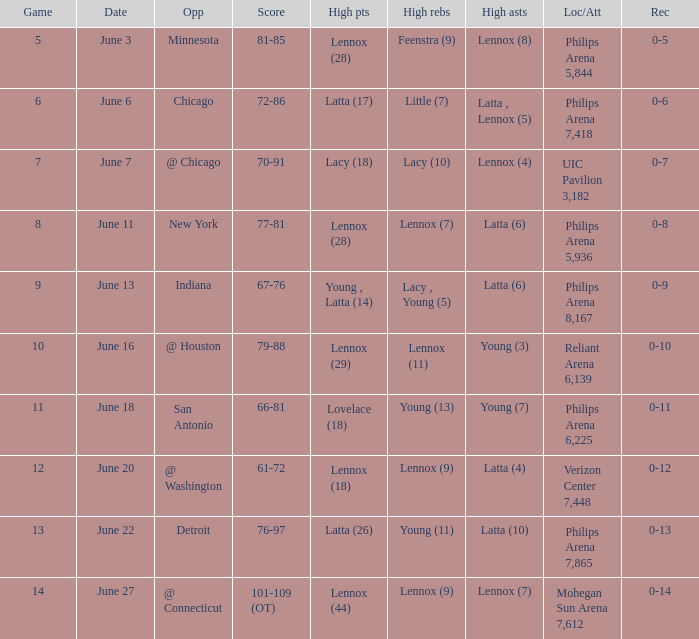What stadium hosted the June 7 game and how many visitors were there? UIC Pavilion 3,182. Could you parse the entire table? {'header': ['Game', 'Date', 'Opp', 'Score', 'High pts', 'High rebs', 'High asts', 'Loc/Att', 'Rec'], 'rows': [['5', 'June 3', 'Minnesota', '81-85', 'Lennox (28)', 'Feenstra (9)', 'Lennox (8)', 'Philips Arena 5,844', '0-5'], ['6', 'June 6', 'Chicago', '72-86', 'Latta (17)', 'Little (7)', 'Latta , Lennox (5)', 'Philips Arena 7,418', '0-6'], ['7', 'June 7', '@ Chicago', '70-91', 'Lacy (18)', 'Lacy (10)', 'Lennox (4)', 'UIC Pavilion 3,182', '0-7'], ['8', 'June 11', 'New York', '77-81', 'Lennox (28)', 'Lennox (7)', 'Latta (6)', 'Philips Arena 5,936', '0-8'], ['9', 'June 13', 'Indiana', '67-76', 'Young , Latta (14)', 'Lacy , Young (5)', 'Latta (6)', 'Philips Arena 8,167', '0-9'], ['10', 'June 16', '@ Houston', '79-88', 'Lennox (29)', 'Lennox (11)', 'Young (3)', 'Reliant Arena 6,139', '0-10'], ['11', 'June 18', 'San Antonio', '66-81', 'Lovelace (18)', 'Young (13)', 'Young (7)', 'Philips Arena 6,225', '0-11'], ['12', 'June 20', '@ Washington', '61-72', 'Lennox (18)', 'Lennox (9)', 'Latta (4)', 'Verizon Center 7,448', '0-12'], ['13', 'June 22', 'Detroit', '76-97', 'Latta (26)', 'Young (11)', 'Latta (10)', 'Philips Arena 7,865', '0-13'], ['14', 'June 27', '@ Connecticut', '101-109 (OT)', 'Lennox (44)', 'Lennox (9)', 'Lennox (7)', 'Mohegan Sun Arena 7,612', '0-14']]} 